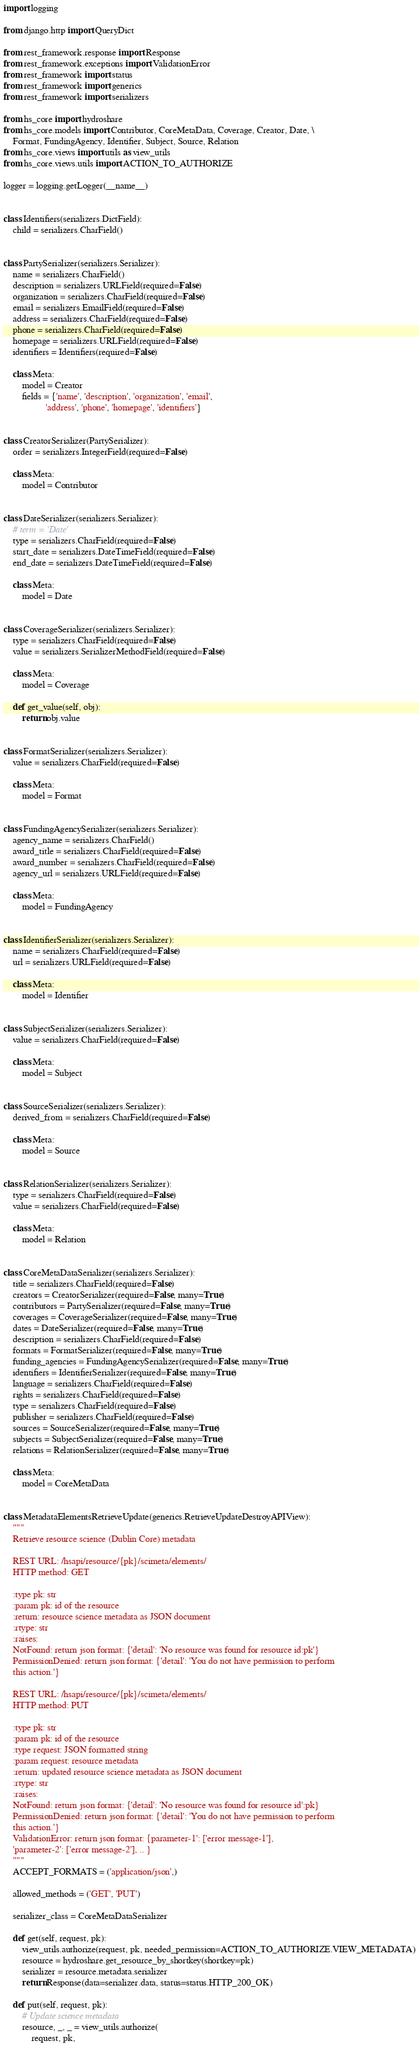Convert code to text. <code><loc_0><loc_0><loc_500><loc_500><_Python_>import logging

from django.http import QueryDict

from rest_framework.response import Response
from rest_framework.exceptions import ValidationError
from rest_framework import status
from rest_framework import generics
from rest_framework import serializers

from hs_core import hydroshare
from hs_core.models import Contributor, CoreMetaData, Coverage, Creator, Date, \
    Format, FundingAgency, Identifier, Subject, Source, Relation
from hs_core.views import utils as view_utils
from hs_core.views.utils import ACTION_TO_AUTHORIZE

logger = logging.getLogger(__name__)


class Identifiers(serializers.DictField):
    child = serializers.CharField()


class PartySerializer(serializers.Serializer):
    name = serializers.CharField()
    description = serializers.URLField(required=False)
    organization = serializers.CharField(required=False)
    email = serializers.EmailField(required=False)
    address = serializers.CharField(required=False)
    phone = serializers.CharField(required=False)
    homepage = serializers.URLField(required=False)
    identifiers = Identifiers(required=False)

    class Meta:
        model = Creator
        fields = {'name', 'description', 'organization', 'email',
                  'address', 'phone', 'homepage', 'identifiers'}


class CreatorSerializer(PartySerializer):
    order = serializers.IntegerField(required=False)

    class Meta:
        model = Contributor


class DateSerializer(serializers.Serializer):
    # term = 'Date'
    type = serializers.CharField(required=False)
    start_date = serializers.DateTimeField(required=False)
    end_date = serializers.DateTimeField(required=False)

    class Meta:
        model = Date


class CoverageSerializer(serializers.Serializer):
    type = serializers.CharField(required=False)
    value = serializers.SerializerMethodField(required=False)

    class Meta:
        model = Coverage

    def get_value(self, obj):
        return obj.value


class FormatSerializer(serializers.Serializer):
    value = serializers.CharField(required=False)

    class Meta:
        model = Format


class FundingAgencySerializer(serializers.Serializer):
    agency_name = serializers.CharField()
    award_title = serializers.CharField(required=False)
    award_number = serializers.CharField(required=False)
    agency_url = serializers.URLField(required=False)

    class Meta:
        model = FundingAgency


class IdentifierSerializer(serializers.Serializer):
    name = serializers.CharField(required=False)
    url = serializers.URLField(required=False)

    class Meta:
        model = Identifier


class SubjectSerializer(serializers.Serializer):
    value = serializers.CharField(required=False)

    class Meta:
        model = Subject


class SourceSerializer(serializers.Serializer):
    derived_from = serializers.CharField(required=False)

    class Meta:
        model = Source


class RelationSerializer(serializers.Serializer):
    type = serializers.CharField(required=False)
    value = serializers.CharField(required=False)

    class Meta:
        model = Relation


class CoreMetaDataSerializer(serializers.Serializer):
    title = serializers.CharField(required=False)
    creators = CreatorSerializer(required=False, many=True)
    contributors = PartySerializer(required=False, many=True)
    coverages = CoverageSerializer(required=False, many=True)
    dates = DateSerializer(required=False, many=True)
    description = serializers.CharField(required=False)
    formats = FormatSerializer(required=False, many=True)
    funding_agencies = FundingAgencySerializer(required=False, many=True)
    identifiers = IdentifierSerializer(required=False, many=True)
    language = serializers.CharField(required=False)
    rights = serializers.CharField(required=False)
    type = serializers.CharField(required=False)
    publisher = serializers.CharField(required=False)
    sources = SourceSerializer(required=False, many=True)
    subjects = SubjectSerializer(required=False, many=True)
    relations = RelationSerializer(required=False, many=True)

    class Meta:
        model = CoreMetaData


class MetadataElementsRetrieveUpdate(generics.RetrieveUpdateDestroyAPIView):
    """
    Retrieve resource science (Dublin Core) metadata

    REST URL: /hsapi/resource/{pk}/scimeta/elements/
    HTTP method: GET

    :type pk: str
    :param pk: id of the resource
    :return: resource science metadata as JSON document
    :rtype: str
    :raises:
    NotFound: return json format: {'detail': 'No resource was found for resource id:pk'}
    PermissionDenied: return json format: {'detail': 'You do not have permission to perform
    this action.'}

    REST URL: /hsapi/resource/{pk}/scimeta/elements/
    HTTP method: PUT

    :type pk: str
    :param pk: id of the resource
    :type request: JSON formatted string
    :param request: resource metadata
    :return: updated resource science metadata as JSON document
    :rtype: str
    :raises:
    NotFound: return json format: {'detail': 'No resource was found for resource id':pk}
    PermissionDenied: return json format: {'detail': 'You do not have permission to perform
    this action.'}
    ValidationError: return json format: {parameter-1': ['error message-1'],
    'parameter-2': ['error message-2'], .. }
    """
    ACCEPT_FORMATS = ('application/json',)

    allowed_methods = ('GET', 'PUT')

    serializer_class = CoreMetaDataSerializer

    def get(self, request, pk):
        view_utils.authorize(request, pk, needed_permission=ACTION_TO_AUTHORIZE.VIEW_METADATA)
        resource = hydroshare.get_resource_by_shortkey(shortkey=pk)
        serializer = resource.metadata.serializer
        return Response(data=serializer.data, status=status.HTTP_200_OK)

    def put(self, request, pk):
        # Update science metadata
        resource, _, _ = view_utils.authorize(
            request, pk,</code> 